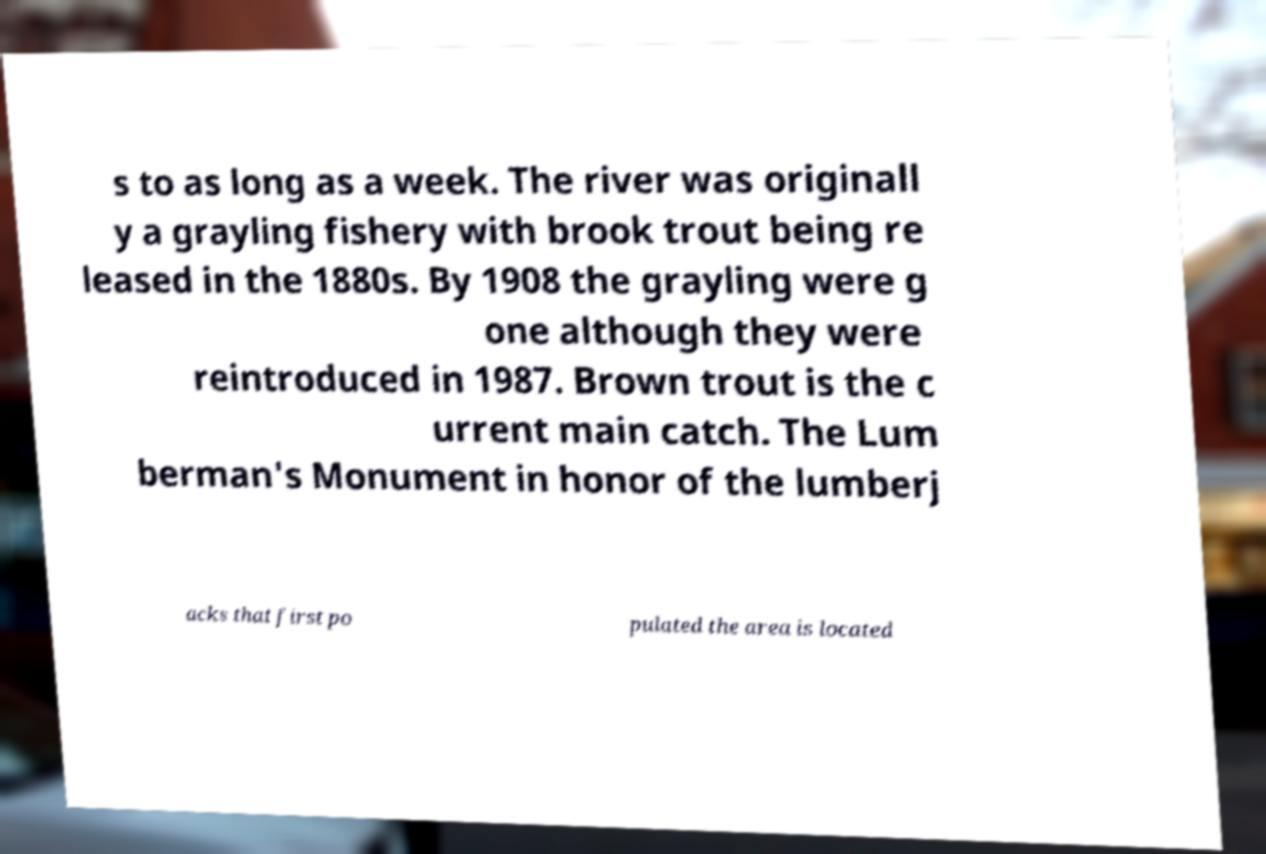Can you read and provide the text displayed in the image?This photo seems to have some interesting text. Can you extract and type it out for me? s to as long as a week. The river was originall y a grayling fishery with brook trout being re leased in the 1880s. By 1908 the grayling were g one although they were reintroduced in 1987. Brown trout is the c urrent main catch. The Lum berman's Monument in honor of the lumberj acks that first po pulated the area is located 